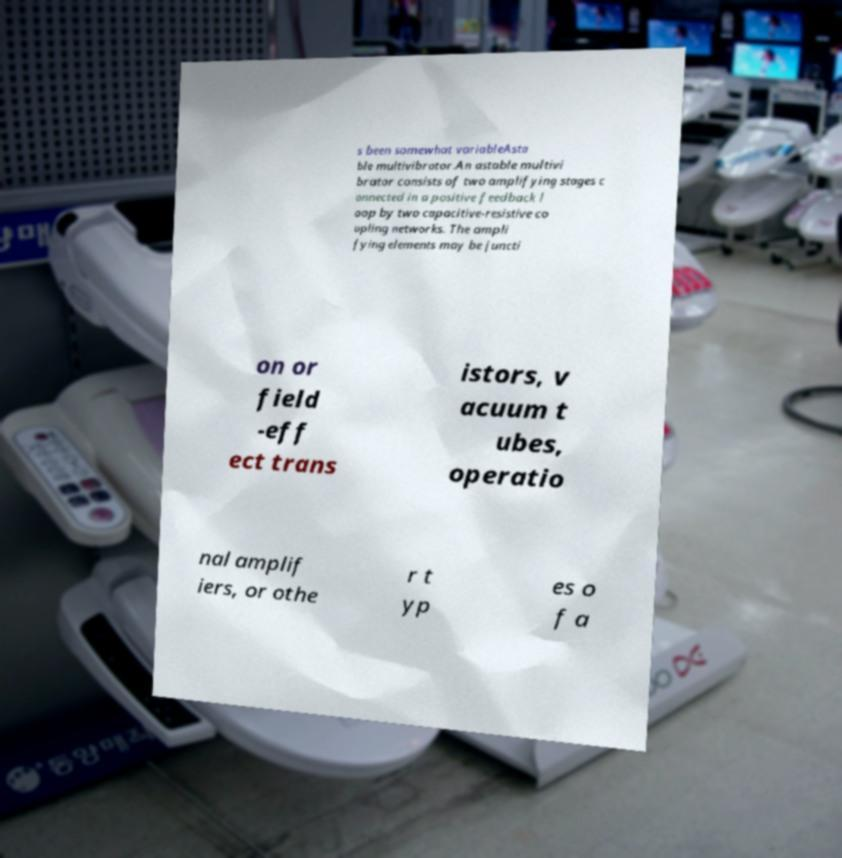Please identify and transcribe the text found in this image. s been somewhat variableAsta ble multivibrator.An astable multivi brator consists of two amplifying stages c onnected in a positive feedback l oop by two capacitive-resistive co upling networks. The ampli fying elements may be juncti on or field -eff ect trans istors, v acuum t ubes, operatio nal amplif iers, or othe r t yp es o f a 